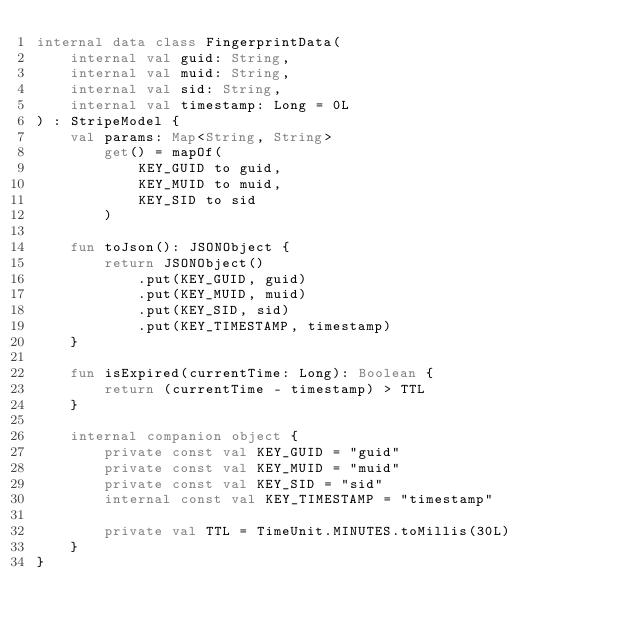<code> <loc_0><loc_0><loc_500><loc_500><_Kotlin_>internal data class FingerprintData(
    internal val guid: String,
    internal val muid: String,
    internal val sid: String,
    internal val timestamp: Long = 0L
) : StripeModel {
    val params: Map<String, String>
        get() = mapOf(
            KEY_GUID to guid,
            KEY_MUID to muid,
            KEY_SID to sid
        )

    fun toJson(): JSONObject {
        return JSONObject()
            .put(KEY_GUID, guid)
            .put(KEY_MUID, muid)
            .put(KEY_SID, sid)
            .put(KEY_TIMESTAMP, timestamp)
    }

    fun isExpired(currentTime: Long): Boolean {
        return (currentTime - timestamp) > TTL
    }

    internal companion object {
        private const val KEY_GUID = "guid"
        private const val KEY_MUID = "muid"
        private const val KEY_SID = "sid"
        internal const val KEY_TIMESTAMP = "timestamp"

        private val TTL = TimeUnit.MINUTES.toMillis(30L)
    }
}
</code> 